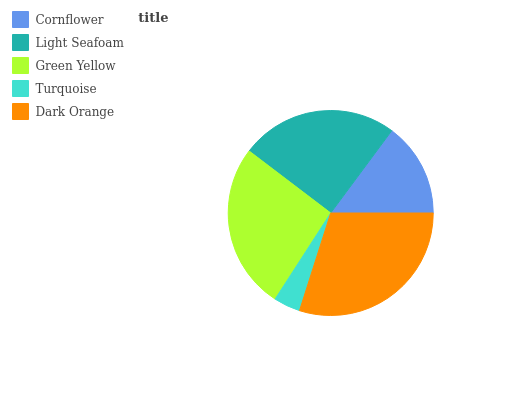Is Turquoise the minimum?
Answer yes or no. Yes. Is Dark Orange the maximum?
Answer yes or no. Yes. Is Light Seafoam the minimum?
Answer yes or no. No. Is Light Seafoam the maximum?
Answer yes or no. No. Is Light Seafoam greater than Cornflower?
Answer yes or no. Yes. Is Cornflower less than Light Seafoam?
Answer yes or no. Yes. Is Cornflower greater than Light Seafoam?
Answer yes or no. No. Is Light Seafoam less than Cornflower?
Answer yes or no. No. Is Light Seafoam the high median?
Answer yes or no. Yes. Is Light Seafoam the low median?
Answer yes or no. Yes. Is Green Yellow the high median?
Answer yes or no. No. Is Dark Orange the low median?
Answer yes or no. No. 